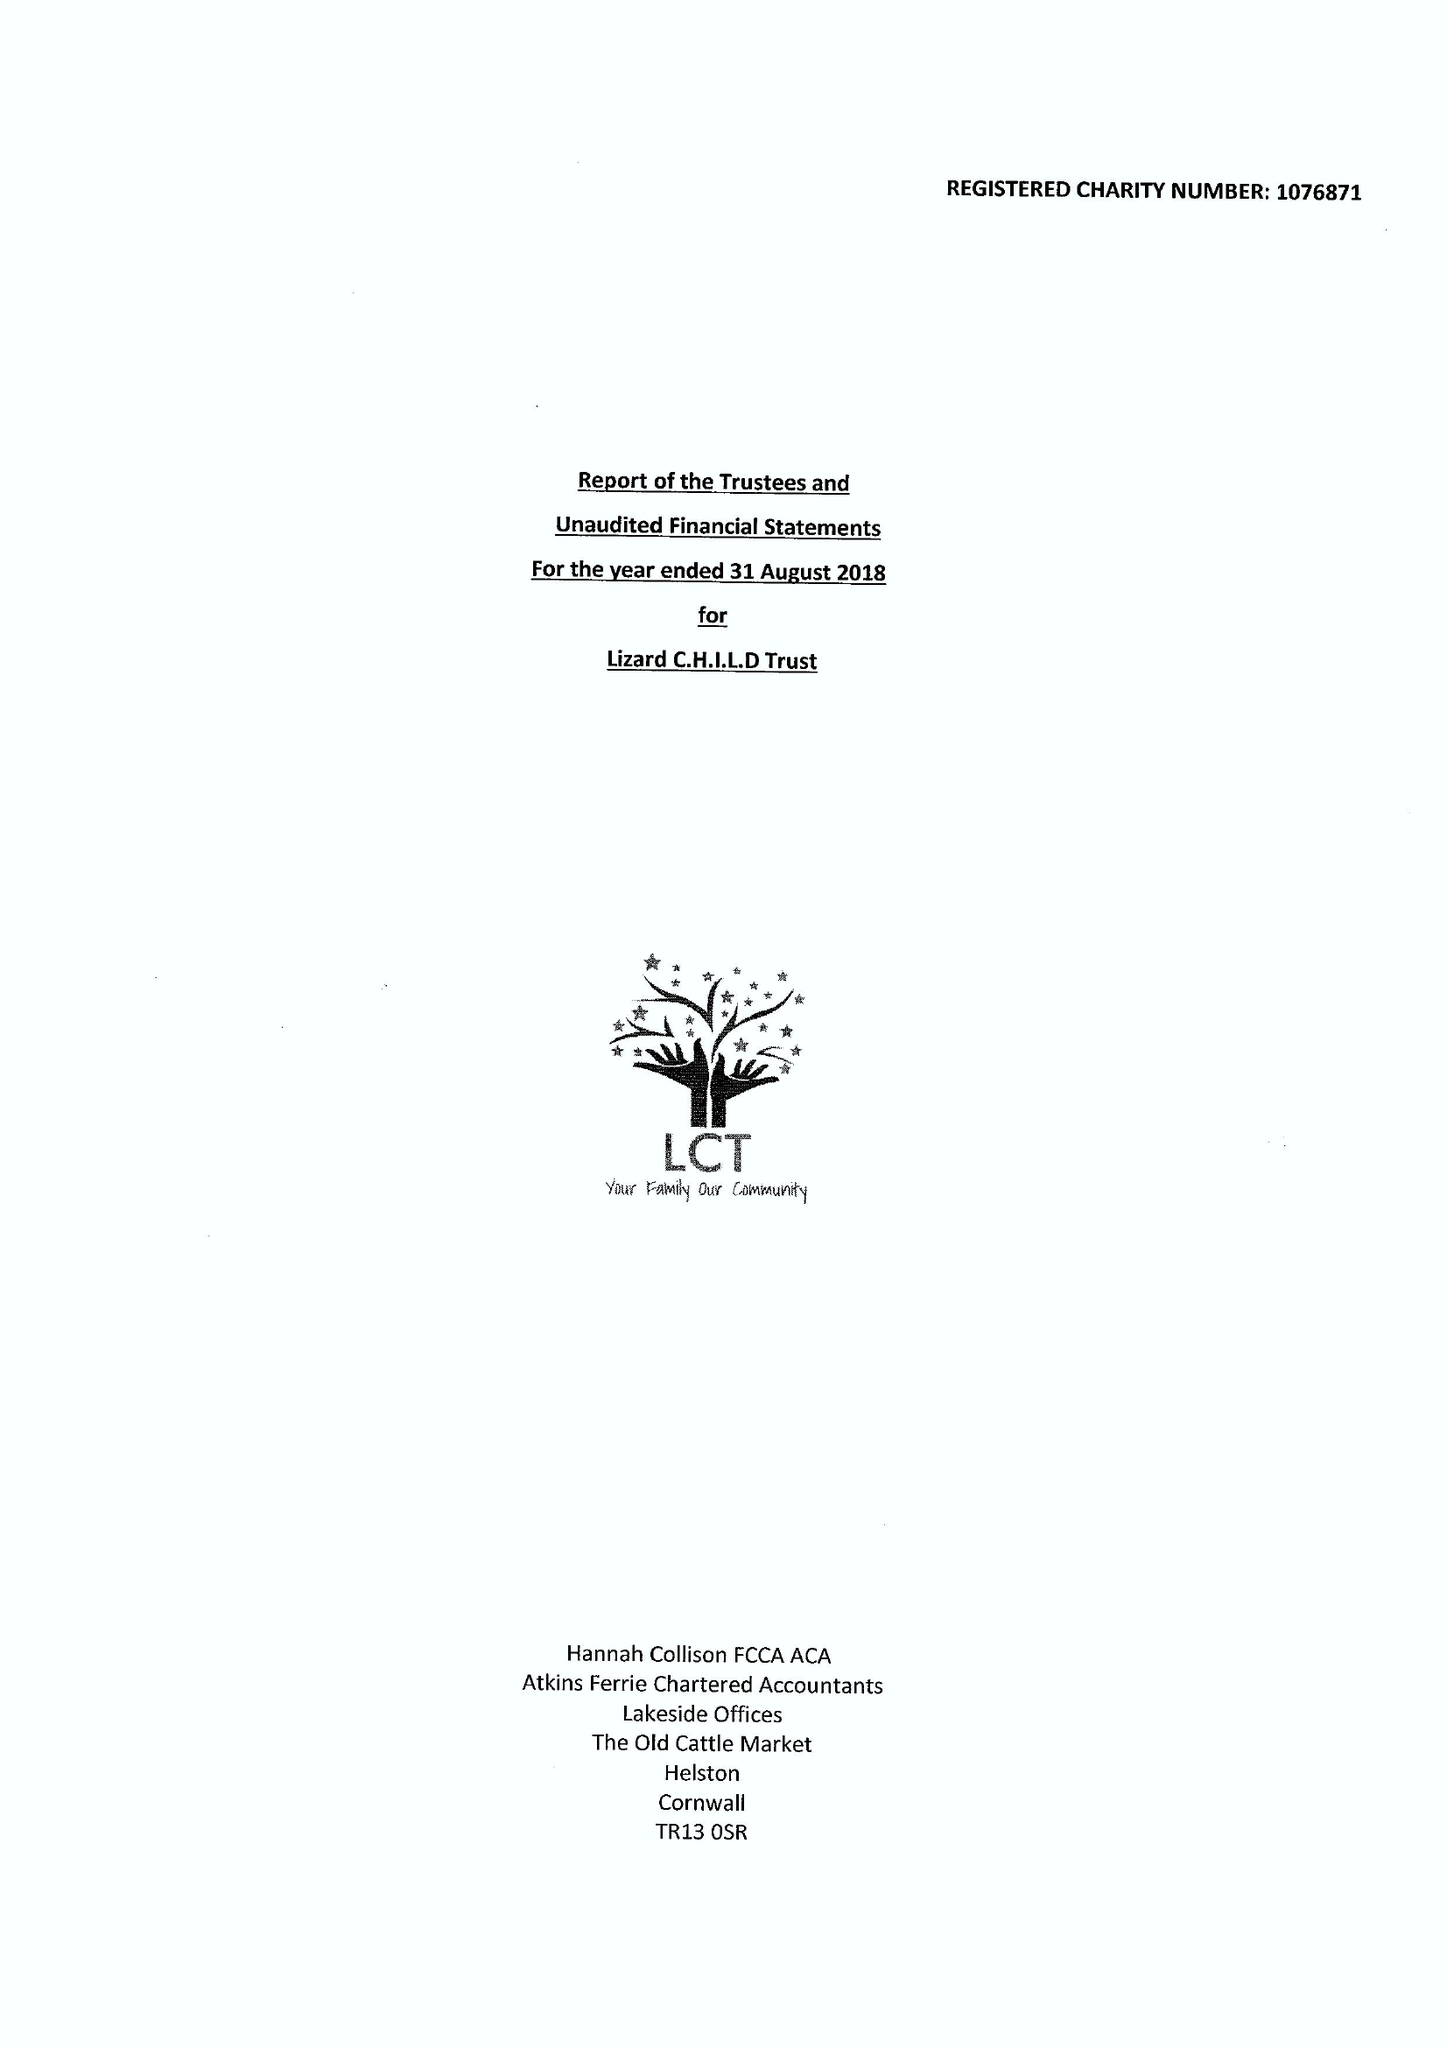What is the value for the charity_number?
Answer the question using a single word or phrase. 1076871 